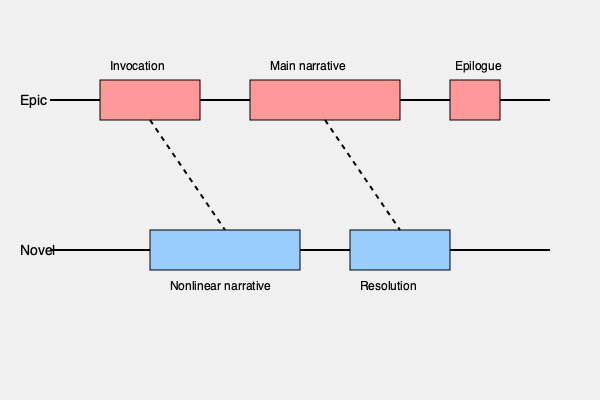Analyze the intersecting timelines of an ancient epic poem and a modern novel as depicted in the graph. How does the narrative structure of the novel diverge from the traditional epic format, and what literary implications does this structural difference suggest? To answer this question, let's analyze the graph step-by-step:

1. Epic poem structure:
   a) Begins with an invocation (first rectangle)
   b) Follows a linear main narrative (middle rectangle)
   c) Concludes with an epilogue (last rectangle)

2. Modern novel structure:
   a) Starts later in the timeline
   b) Has two main sections: a longer nonlinear narrative and a shorter resolution

3. Key differences:
   a) Starting point: The novel lacks the traditional epic invocation
   b) Narrative approach: Epic is linear, while the novel is nonlinear
   c) Conclusion: Epic has an epilogue, novel has a resolution section

4. Intersections:
   Two purple dotted lines connect the epic and novel timelines, suggesting thematic or structural connections between the ancient and modern forms.

5. Literary implications:
   a) Modernist/postmodernist influence: The novel's nonlinear structure reflects contemporary storytelling techniques
   b) Complexity: The novel's structure allows for multiple perspectives, timelines, or narrative threads
   c) Reader engagement: Nonlinear structure may require more active participation from the reader
   d) Thematic connections: Despite structural differences, the intersecting lines suggest that modern novels still draw inspiration from or reference epic traditions

6. Evolution of narrative:
   The graph illustrates the evolution of storytelling from the structured, linear approach of epics to the more experimental, fragmented style of modern novels.
Answer: The novel diverges through nonlinear narrative and absence of invocation, implying increased complexity, reader engagement, and a modernist approach while maintaining thematic connections to epic traditions. 